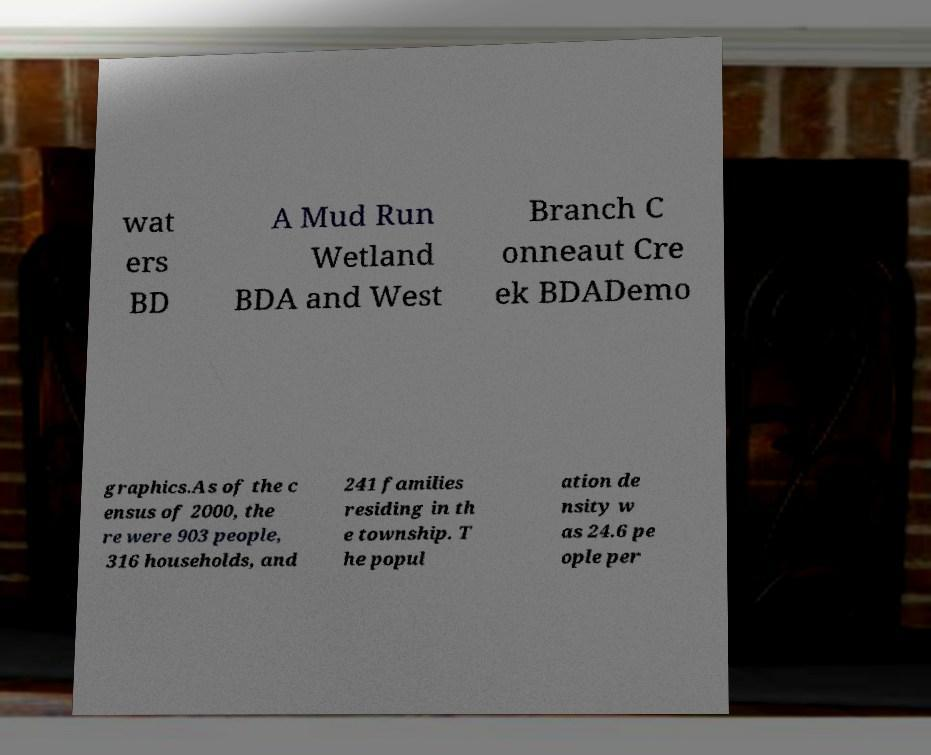Could you extract and type out the text from this image? wat ers BD A Mud Run Wetland BDA and West Branch C onneaut Cre ek BDADemo graphics.As of the c ensus of 2000, the re were 903 people, 316 households, and 241 families residing in th e township. T he popul ation de nsity w as 24.6 pe ople per 